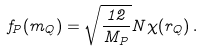<formula> <loc_0><loc_0><loc_500><loc_500>f _ { P } ( m _ { Q } ) = \sqrt { \frac { 1 2 } { M _ { P } } } N \chi ( r _ { Q } ) \, .</formula> 